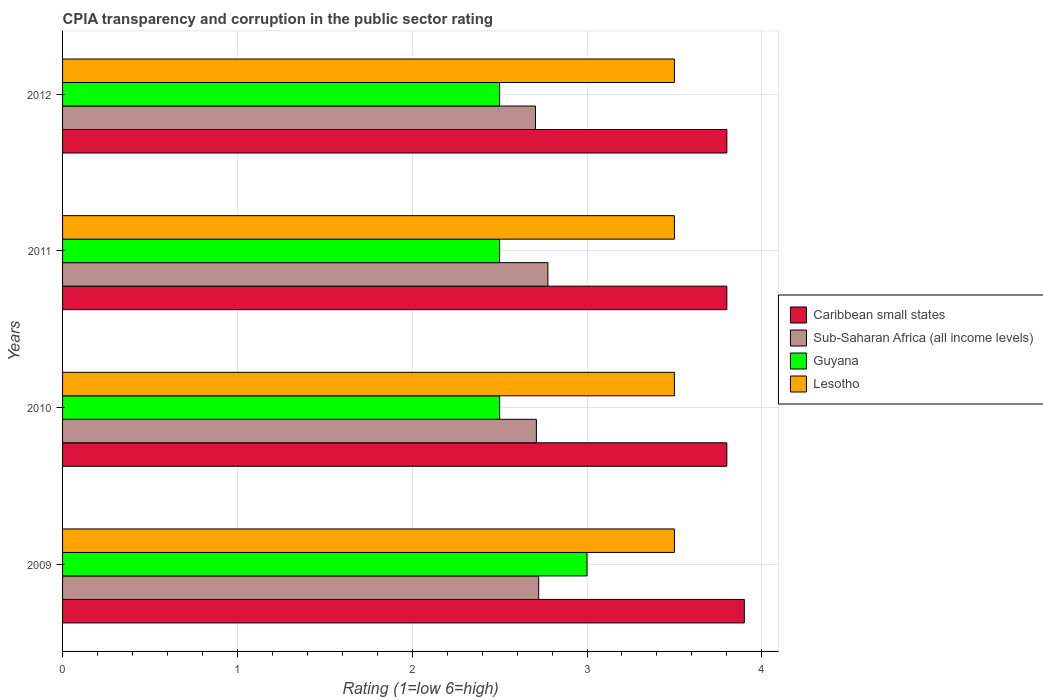How many different coloured bars are there?
Make the answer very short. 4. Are the number of bars per tick equal to the number of legend labels?
Provide a succinct answer. Yes. How many bars are there on the 4th tick from the top?
Make the answer very short. 4. How many bars are there on the 3rd tick from the bottom?
Give a very brief answer. 4. What is the label of the 1st group of bars from the top?
Keep it short and to the point. 2012. In how many cases, is the number of bars for a given year not equal to the number of legend labels?
Your answer should be compact. 0. Across all years, what is the minimum CPIA rating in Guyana?
Offer a terse response. 2.5. In which year was the CPIA rating in Lesotho maximum?
Make the answer very short. 2009. In which year was the CPIA rating in Caribbean small states minimum?
Offer a terse response. 2010. What is the difference between the CPIA rating in Caribbean small states in 2010 and that in 2011?
Make the answer very short. 0. What is the difference between the CPIA rating in Sub-Saharan Africa (all income levels) in 2010 and the CPIA rating in Guyana in 2012?
Ensure brevity in your answer.  0.21. What is the average CPIA rating in Sub-Saharan Africa (all income levels) per year?
Ensure brevity in your answer.  2.73. In the year 2012, what is the difference between the CPIA rating in Lesotho and CPIA rating in Caribbean small states?
Keep it short and to the point. -0.3. In how many years, is the CPIA rating in Caribbean small states greater than 1 ?
Your answer should be very brief. 4. What is the ratio of the CPIA rating in Lesotho in 2010 to that in 2012?
Provide a short and direct response. 1. What is the difference between the highest and the second highest CPIA rating in Caribbean small states?
Your answer should be very brief. 0.1. Is it the case that in every year, the sum of the CPIA rating in Lesotho and CPIA rating in Sub-Saharan Africa (all income levels) is greater than the sum of CPIA rating in Guyana and CPIA rating in Caribbean small states?
Make the answer very short. No. What does the 3rd bar from the top in 2009 represents?
Your answer should be very brief. Sub-Saharan Africa (all income levels). What does the 1st bar from the bottom in 2011 represents?
Your response must be concise. Caribbean small states. Is it the case that in every year, the sum of the CPIA rating in Caribbean small states and CPIA rating in Guyana is greater than the CPIA rating in Sub-Saharan Africa (all income levels)?
Keep it short and to the point. Yes. Are the values on the major ticks of X-axis written in scientific E-notation?
Offer a terse response. No. How are the legend labels stacked?
Give a very brief answer. Vertical. What is the title of the graph?
Make the answer very short. CPIA transparency and corruption in the public sector rating. Does "Tajikistan" appear as one of the legend labels in the graph?
Ensure brevity in your answer.  No. What is the label or title of the X-axis?
Your response must be concise. Rating (1=low 6=high). What is the label or title of the Y-axis?
Make the answer very short. Years. What is the Rating (1=low 6=high) in Caribbean small states in 2009?
Keep it short and to the point. 3.9. What is the Rating (1=low 6=high) of Sub-Saharan Africa (all income levels) in 2009?
Keep it short and to the point. 2.72. What is the Rating (1=low 6=high) in Guyana in 2009?
Provide a short and direct response. 3. What is the Rating (1=low 6=high) in Lesotho in 2009?
Offer a terse response. 3.5. What is the Rating (1=low 6=high) of Sub-Saharan Africa (all income levels) in 2010?
Offer a terse response. 2.71. What is the Rating (1=low 6=high) in Guyana in 2010?
Your answer should be compact. 2.5. What is the Rating (1=low 6=high) of Lesotho in 2010?
Your response must be concise. 3.5. What is the Rating (1=low 6=high) in Sub-Saharan Africa (all income levels) in 2011?
Provide a short and direct response. 2.78. What is the Rating (1=low 6=high) in Lesotho in 2011?
Provide a succinct answer. 3.5. What is the Rating (1=low 6=high) of Caribbean small states in 2012?
Your answer should be very brief. 3.8. What is the Rating (1=low 6=high) of Sub-Saharan Africa (all income levels) in 2012?
Give a very brief answer. 2.71. What is the Rating (1=low 6=high) in Guyana in 2012?
Ensure brevity in your answer.  2.5. Across all years, what is the maximum Rating (1=low 6=high) in Caribbean small states?
Provide a short and direct response. 3.9. Across all years, what is the maximum Rating (1=low 6=high) of Sub-Saharan Africa (all income levels)?
Ensure brevity in your answer.  2.78. Across all years, what is the maximum Rating (1=low 6=high) in Guyana?
Keep it short and to the point. 3. Across all years, what is the minimum Rating (1=low 6=high) of Sub-Saharan Africa (all income levels)?
Give a very brief answer. 2.71. Across all years, what is the minimum Rating (1=low 6=high) of Guyana?
Ensure brevity in your answer.  2.5. Across all years, what is the minimum Rating (1=low 6=high) of Lesotho?
Offer a terse response. 3.5. What is the total Rating (1=low 6=high) of Sub-Saharan Africa (all income levels) in the graph?
Offer a terse response. 10.92. What is the total Rating (1=low 6=high) of Guyana in the graph?
Offer a very short reply. 10.5. What is the total Rating (1=low 6=high) of Lesotho in the graph?
Offer a terse response. 14. What is the difference between the Rating (1=low 6=high) of Caribbean small states in 2009 and that in 2010?
Your answer should be very brief. 0.1. What is the difference between the Rating (1=low 6=high) in Sub-Saharan Africa (all income levels) in 2009 and that in 2010?
Give a very brief answer. 0.01. What is the difference between the Rating (1=low 6=high) in Guyana in 2009 and that in 2010?
Make the answer very short. 0.5. What is the difference between the Rating (1=low 6=high) in Lesotho in 2009 and that in 2010?
Your response must be concise. 0. What is the difference between the Rating (1=low 6=high) of Sub-Saharan Africa (all income levels) in 2009 and that in 2011?
Your response must be concise. -0.05. What is the difference between the Rating (1=low 6=high) of Lesotho in 2009 and that in 2011?
Keep it short and to the point. 0. What is the difference between the Rating (1=low 6=high) in Caribbean small states in 2009 and that in 2012?
Offer a very short reply. 0.1. What is the difference between the Rating (1=low 6=high) of Sub-Saharan Africa (all income levels) in 2009 and that in 2012?
Give a very brief answer. 0.02. What is the difference between the Rating (1=low 6=high) of Guyana in 2009 and that in 2012?
Your answer should be compact. 0.5. What is the difference between the Rating (1=low 6=high) in Sub-Saharan Africa (all income levels) in 2010 and that in 2011?
Keep it short and to the point. -0.07. What is the difference between the Rating (1=low 6=high) of Guyana in 2010 and that in 2011?
Offer a terse response. 0. What is the difference between the Rating (1=low 6=high) of Sub-Saharan Africa (all income levels) in 2010 and that in 2012?
Make the answer very short. 0.01. What is the difference between the Rating (1=low 6=high) in Sub-Saharan Africa (all income levels) in 2011 and that in 2012?
Offer a very short reply. 0.07. What is the difference between the Rating (1=low 6=high) of Caribbean small states in 2009 and the Rating (1=low 6=high) of Sub-Saharan Africa (all income levels) in 2010?
Give a very brief answer. 1.19. What is the difference between the Rating (1=low 6=high) in Caribbean small states in 2009 and the Rating (1=low 6=high) in Lesotho in 2010?
Make the answer very short. 0.4. What is the difference between the Rating (1=low 6=high) of Sub-Saharan Africa (all income levels) in 2009 and the Rating (1=low 6=high) of Guyana in 2010?
Your response must be concise. 0.22. What is the difference between the Rating (1=low 6=high) in Sub-Saharan Africa (all income levels) in 2009 and the Rating (1=low 6=high) in Lesotho in 2010?
Provide a succinct answer. -0.78. What is the difference between the Rating (1=low 6=high) in Guyana in 2009 and the Rating (1=low 6=high) in Lesotho in 2010?
Your response must be concise. -0.5. What is the difference between the Rating (1=low 6=high) of Caribbean small states in 2009 and the Rating (1=low 6=high) of Sub-Saharan Africa (all income levels) in 2011?
Offer a very short reply. 1.12. What is the difference between the Rating (1=low 6=high) in Caribbean small states in 2009 and the Rating (1=low 6=high) in Guyana in 2011?
Make the answer very short. 1.4. What is the difference between the Rating (1=low 6=high) of Caribbean small states in 2009 and the Rating (1=low 6=high) of Lesotho in 2011?
Keep it short and to the point. 0.4. What is the difference between the Rating (1=low 6=high) of Sub-Saharan Africa (all income levels) in 2009 and the Rating (1=low 6=high) of Guyana in 2011?
Give a very brief answer. 0.22. What is the difference between the Rating (1=low 6=high) of Sub-Saharan Africa (all income levels) in 2009 and the Rating (1=low 6=high) of Lesotho in 2011?
Offer a terse response. -0.78. What is the difference between the Rating (1=low 6=high) of Caribbean small states in 2009 and the Rating (1=low 6=high) of Sub-Saharan Africa (all income levels) in 2012?
Give a very brief answer. 1.19. What is the difference between the Rating (1=low 6=high) in Caribbean small states in 2009 and the Rating (1=low 6=high) in Lesotho in 2012?
Offer a very short reply. 0.4. What is the difference between the Rating (1=low 6=high) of Sub-Saharan Africa (all income levels) in 2009 and the Rating (1=low 6=high) of Guyana in 2012?
Provide a short and direct response. 0.22. What is the difference between the Rating (1=low 6=high) of Sub-Saharan Africa (all income levels) in 2009 and the Rating (1=low 6=high) of Lesotho in 2012?
Offer a terse response. -0.78. What is the difference between the Rating (1=low 6=high) in Guyana in 2009 and the Rating (1=low 6=high) in Lesotho in 2012?
Your answer should be very brief. -0.5. What is the difference between the Rating (1=low 6=high) of Caribbean small states in 2010 and the Rating (1=low 6=high) of Sub-Saharan Africa (all income levels) in 2011?
Provide a succinct answer. 1.02. What is the difference between the Rating (1=low 6=high) of Caribbean small states in 2010 and the Rating (1=low 6=high) of Lesotho in 2011?
Make the answer very short. 0.3. What is the difference between the Rating (1=low 6=high) in Sub-Saharan Africa (all income levels) in 2010 and the Rating (1=low 6=high) in Guyana in 2011?
Offer a terse response. 0.21. What is the difference between the Rating (1=low 6=high) of Sub-Saharan Africa (all income levels) in 2010 and the Rating (1=low 6=high) of Lesotho in 2011?
Your answer should be very brief. -0.79. What is the difference between the Rating (1=low 6=high) in Caribbean small states in 2010 and the Rating (1=low 6=high) in Sub-Saharan Africa (all income levels) in 2012?
Your answer should be very brief. 1.09. What is the difference between the Rating (1=low 6=high) of Caribbean small states in 2010 and the Rating (1=low 6=high) of Lesotho in 2012?
Provide a succinct answer. 0.3. What is the difference between the Rating (1=low 6=high) of Sub-Saharan Africa (all income levels) in 2010 and the Rating (1=low 6=high) of Guyana in 2012?
Provide a short and direct response. 0.21. What is the difference between the Rating (1=low 6=high) in Sub-Saharan Africa (all income levels) in 2010 and the Rating (1=low 6=high) in Lesotho in 2012?
Your response must be concise. -0.79. What is the difference between the Rating (1=low 6=high) of Guyana in 2010 and the Rating (1=low 6=high) of Lesotho in 2012?
Ensure brevity in your answer.  -1. What is the difference between the Rating (1=low 6=high) of Caribbean small states in 2011 and the Rating (1=low 6=high) of Sub-Saharan Africa (all income levels) in 2012?
Offer a terse response. 1.09. What is the difference between the Rating (1=low 6=high) of Caribbean small states in 2011 and the Rating (1=low 6=high) of Guyana in 2012?
Your answer should be very brief. 1.3. What is the difference between the Rating (1=low 6=high) of Sub-Saharan Africa (all income levels) in 2011 and the Rating (1=low 6=high) of Guyana in 2012?
Provide a short and direct response. 0.28. What is the difference between the Rating (1=low 6=high) in Sub-Saharan Africa (all income levels) in 2011 and the Rating (1=low 6=high) in Lesotho in 2012?
Offer a very short reply. -0.72. What is the average Rating (1=low 6=high) of Caribbean small states per year?
Your response must be concise. 3.83. What is the average Rating (1=low 6=high) of Sub-Saharan Africa (all income levels) per year?
Offer a very short reply. 2.73. What is the average Rating (1=low 6=high) of Guyana per year?
Provide a short and direct response. 2.62. In the year 2009, what is the difference between the Rating (1=low 6=high) of Caribbean small states and Rating (1=low 6=high) of Sub-Saharan Africa (all income levels)?
Make the answer very short. 1.18. In the year 2009, what is the difference between the Rating (1=low 6=high) of Sub-Saharan Africa (all income levels) and Rating (1=low 6=high) of Guyana?
Provide a short and direct response. -0.28. In the year 2009, what is the difference between the Rating (1=low 6=high) of Sub-Saharan Africa (all income levels) and Rating (1=low 6=high) of Lesotho?
Keep it short and to the point. -0.78. In the year 2010, what is the difference between the Rating (1=low 6=high) of Caribbean small states and Rating (1=low 6=high) of Sub-Saharan Africa (all income levels)?
Your response must be concise. 1.09. In the year 2010, what is the difference between the Rating (1=low 6=high) in Sub-Saharan Africa (all income levels) and Rating (1=low 6=high) in Guyana?
Offer a terse response. 0.21. In the year 2010, what is the difference between the Rating (1=low 6=high) in Sub-Saharan Africa (all income levels) and Rating (1=low 6=high) in Lesotho?
Your answer should be very brief. -0.79. In the year 2011, what is the difference between the Rating (1=low 6=high) of Caribbean small states and Rating (1=low 6=high) of Sub-Saharan Africa (all income levels)?
Provide a short and direct response. 1.02. In the year 2011, what is the difference between the Rating (1=low 6=high) of Caribbean small states and Rating (1=low 6=high) of Lesotho?
Keep it short and to the point. 0.3. In the year 2011, what is the difference between the Rating (1=low 6=high) in Sub-Saharan Africa (all income levels) and Rating (1=low 6=high) in Guyana?
Your response must be concise. 0.28. In the year 2011, what is the difference between the Rating (1=low 6=high) of Sub-Saharan Africa (all income levels) and Rating (1=low 6=high) of Lesotho?
Provide a short and direct response. -0.72. In the year 2012, what is the difference between the Rating (1=low 6=high) in Caribbean small states and Rating (1=low 6=high) in Sub-Saharan Africa (all income levels)?
Your answer should be very brief. 1.09. In the year 2012, what is the difference between the Rating (1=low 6=high) in Caribbean small states and Rating (1=low 6=high) in Guyana?
Your answer should be very brief. 1.3. In the year 2012, what is the difference between the Rating (1=low 6=high) in Caribbean small states and Rating (1=low 6=high) in Lesotho?
Keep it short and to the point. 0.3. In the year 2012, what is the difference between the Rating (1=low 6=high) of Sub-Saharan Africa (all income levels) and Rating (1=low 6=high) of Guyana?
Keep it short and to the point. 0.21. In the year 2012, what is the difference between the Rating (1=low 6=high) of Sub-Saharan Africa (all income levels) and Rating (1=low 6=high) of Lesotho?
Make the answer very short. -0.79. What is the ratio of the Rating (1=low 6=high) of Caribbean small states in 2009 to that in 2010?
Make the answer very short. 1.03. What is the ratio of the Rating (1=low 6=high) of Caribbean small states in 2009 to that in 2011?
Give a very brief answer. 1.03. What is the ratio of the Rating (1=low 6=high) in Caribbean small states in 2009 to that in 2012?
Keep it short and to the point. 1.03. What is the ratio of the Rating (1=low 6=high) of Guyana in 2009 to that in 2012?
Provide a short and direct response. 1.2. What is the ratio of the Rating (1=low 6=high) of Caribbean small states in 2010 to that in 2011?
Your response must be concise. 1. What is the ratio of the Rating (1=low 6=high) of Sub-Saharan Africa (all income levels) in 2010 to that in 2011?
Provide a succinct answer. 0.98. What is the ratio of the Rating (1=low 6=high) of Guyana in 2010 to that in 2011?
Offer a very short reply. 1. What is the ratio of the Rating (1=low 6=high) in Caribbean small states in 2011 to that in 2012?
Your answer should be very brief. 1. What is the ratio of the Rating (1=low 6=high) in Sub-Saharan Africa (all income levels) in 2011 to that in 2012?
Your answer should be very brief. 1.03. What is the difference between the highest and the second highest Rating (1=low 6=high) in Caribbean small states?
Provide a short and direct response. 0.1. What is the difference between the highest and the second highest Rating (1=low 6=high) in Sub-Saharan Africa (all income levels)?
Your answer should be very brief. 0.05. What is the difference between the highest and the lowest Rating (1=low 6=high) in Caribbean small states?
Your answer should be compact. 0.1. What is the difference between the highest and the lowest Rating (1=low 6=high) of Sub-Saharan Africa (all income levels)?
Your response must be concise. 0.07. What is the difference between the highest and the lowest Rating (1=low 6=high) in Lesotho?
Offer a terse response. 0. 